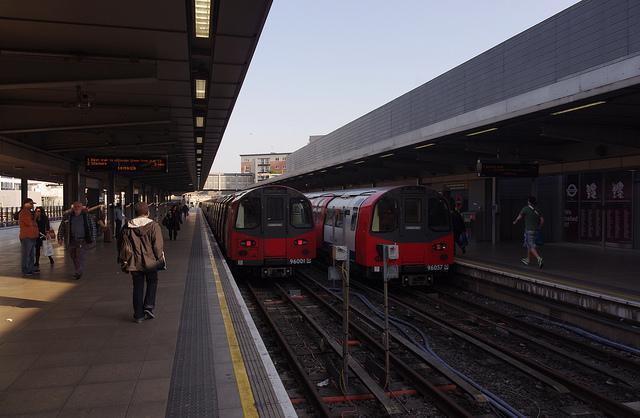What information does such an electronic billboard depict in this scenario?
Make your selection from the four choices given to correctly answer the question.
Options: Train, weather, stock market, politics. Train. 